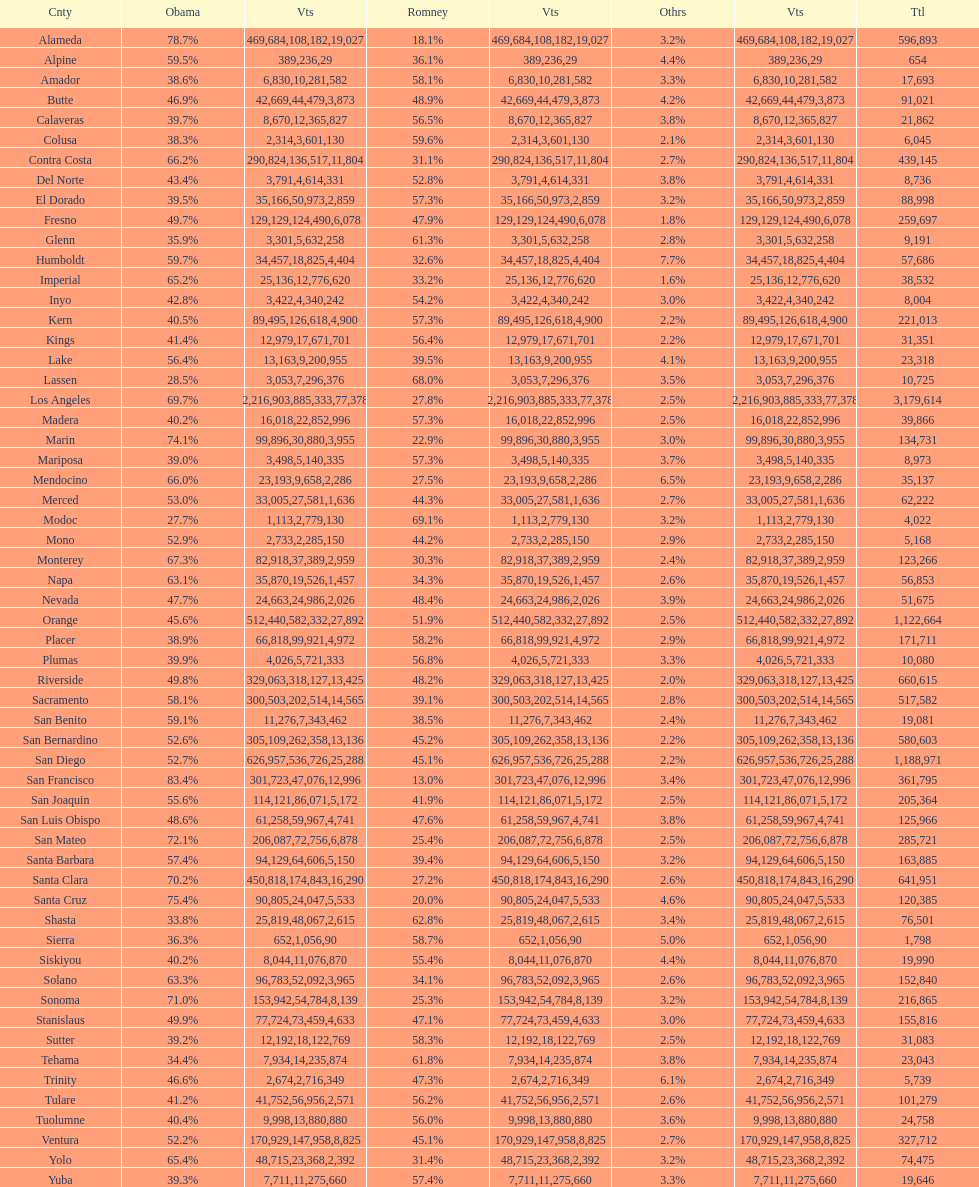Did romney earn more or less votes than obama did in alameda county? Less. 